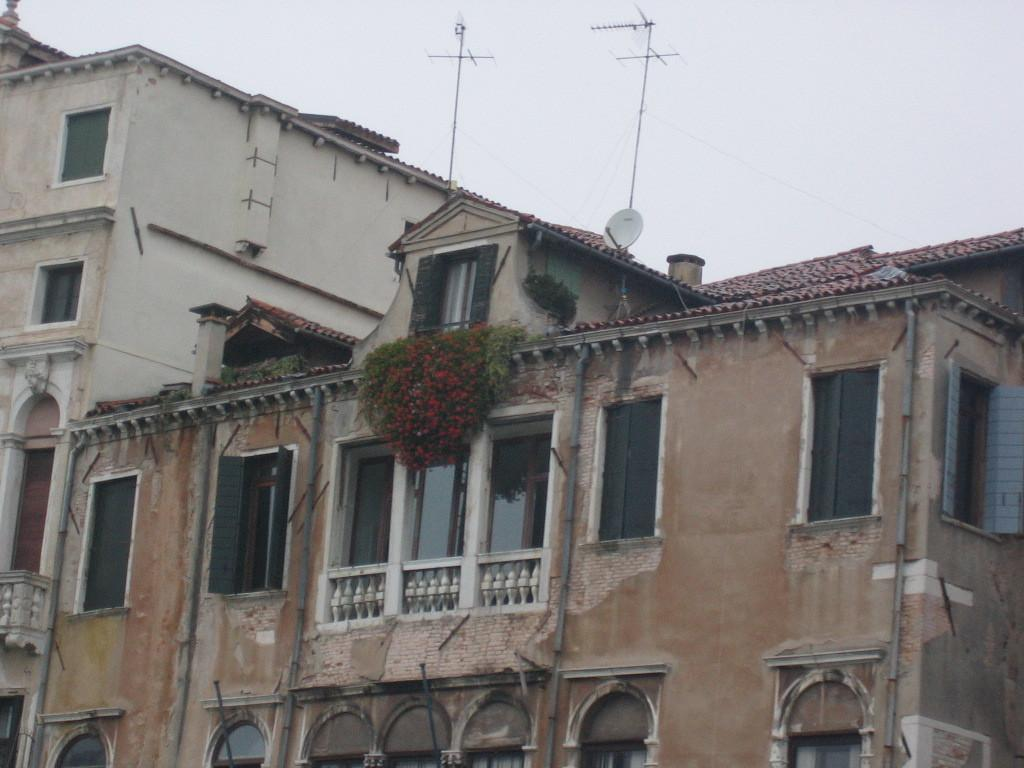What type of structures can be seen in the image? There are buildings in the image. What other elements are present in the image besides buildings? There are plants, flowers, a rooftop, and a window visible in the image. What is visible at the top of the image? The sky is visible at the top of the image. What type of chess move is being made by the flowers in the image? There is no chess move being made by the flowers in the image, as chess is a game played with pieces and not flowers. 